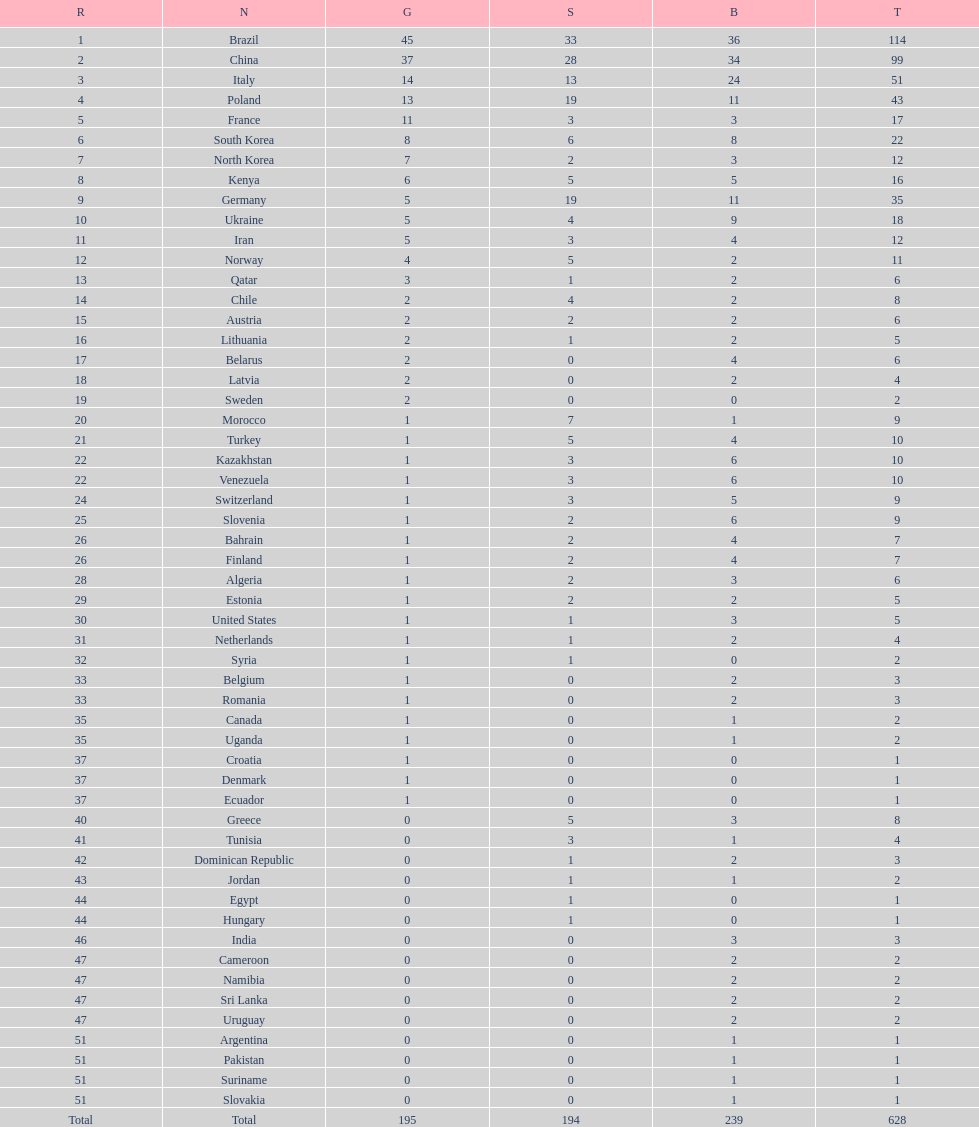How many gold medals did germany earn? 5. 